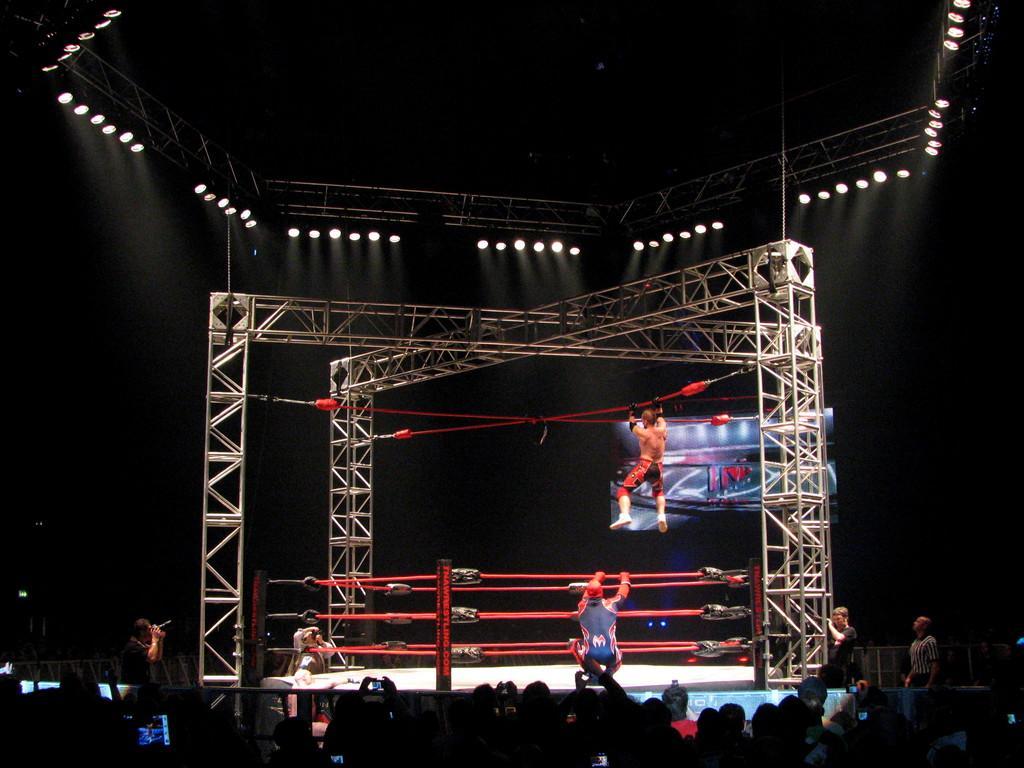In one or two sentences, can you explain what this image depicts? In this image at the bottom the image is dark but we can see few persons and objects. There is a person in squat position on the stage at the ropes and there is another person in the air and holding the rope in the hands. At the top we can see lights on the rods. In the background the image is dark. 